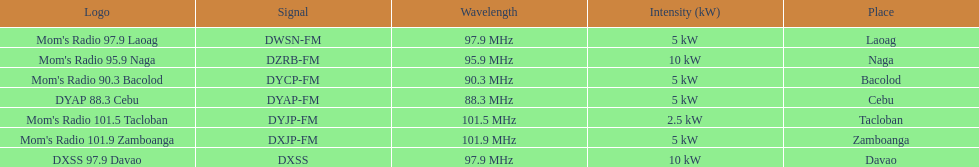What is the radio with the most mhz? Mom's Radio 101.9 Zamboanga. 